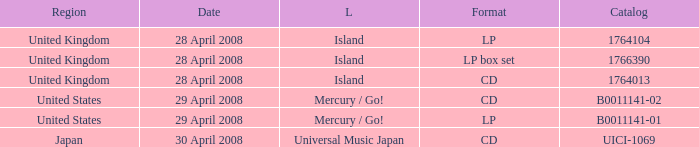What is the Region of the 1766390 Catalog? United Kingdom. 